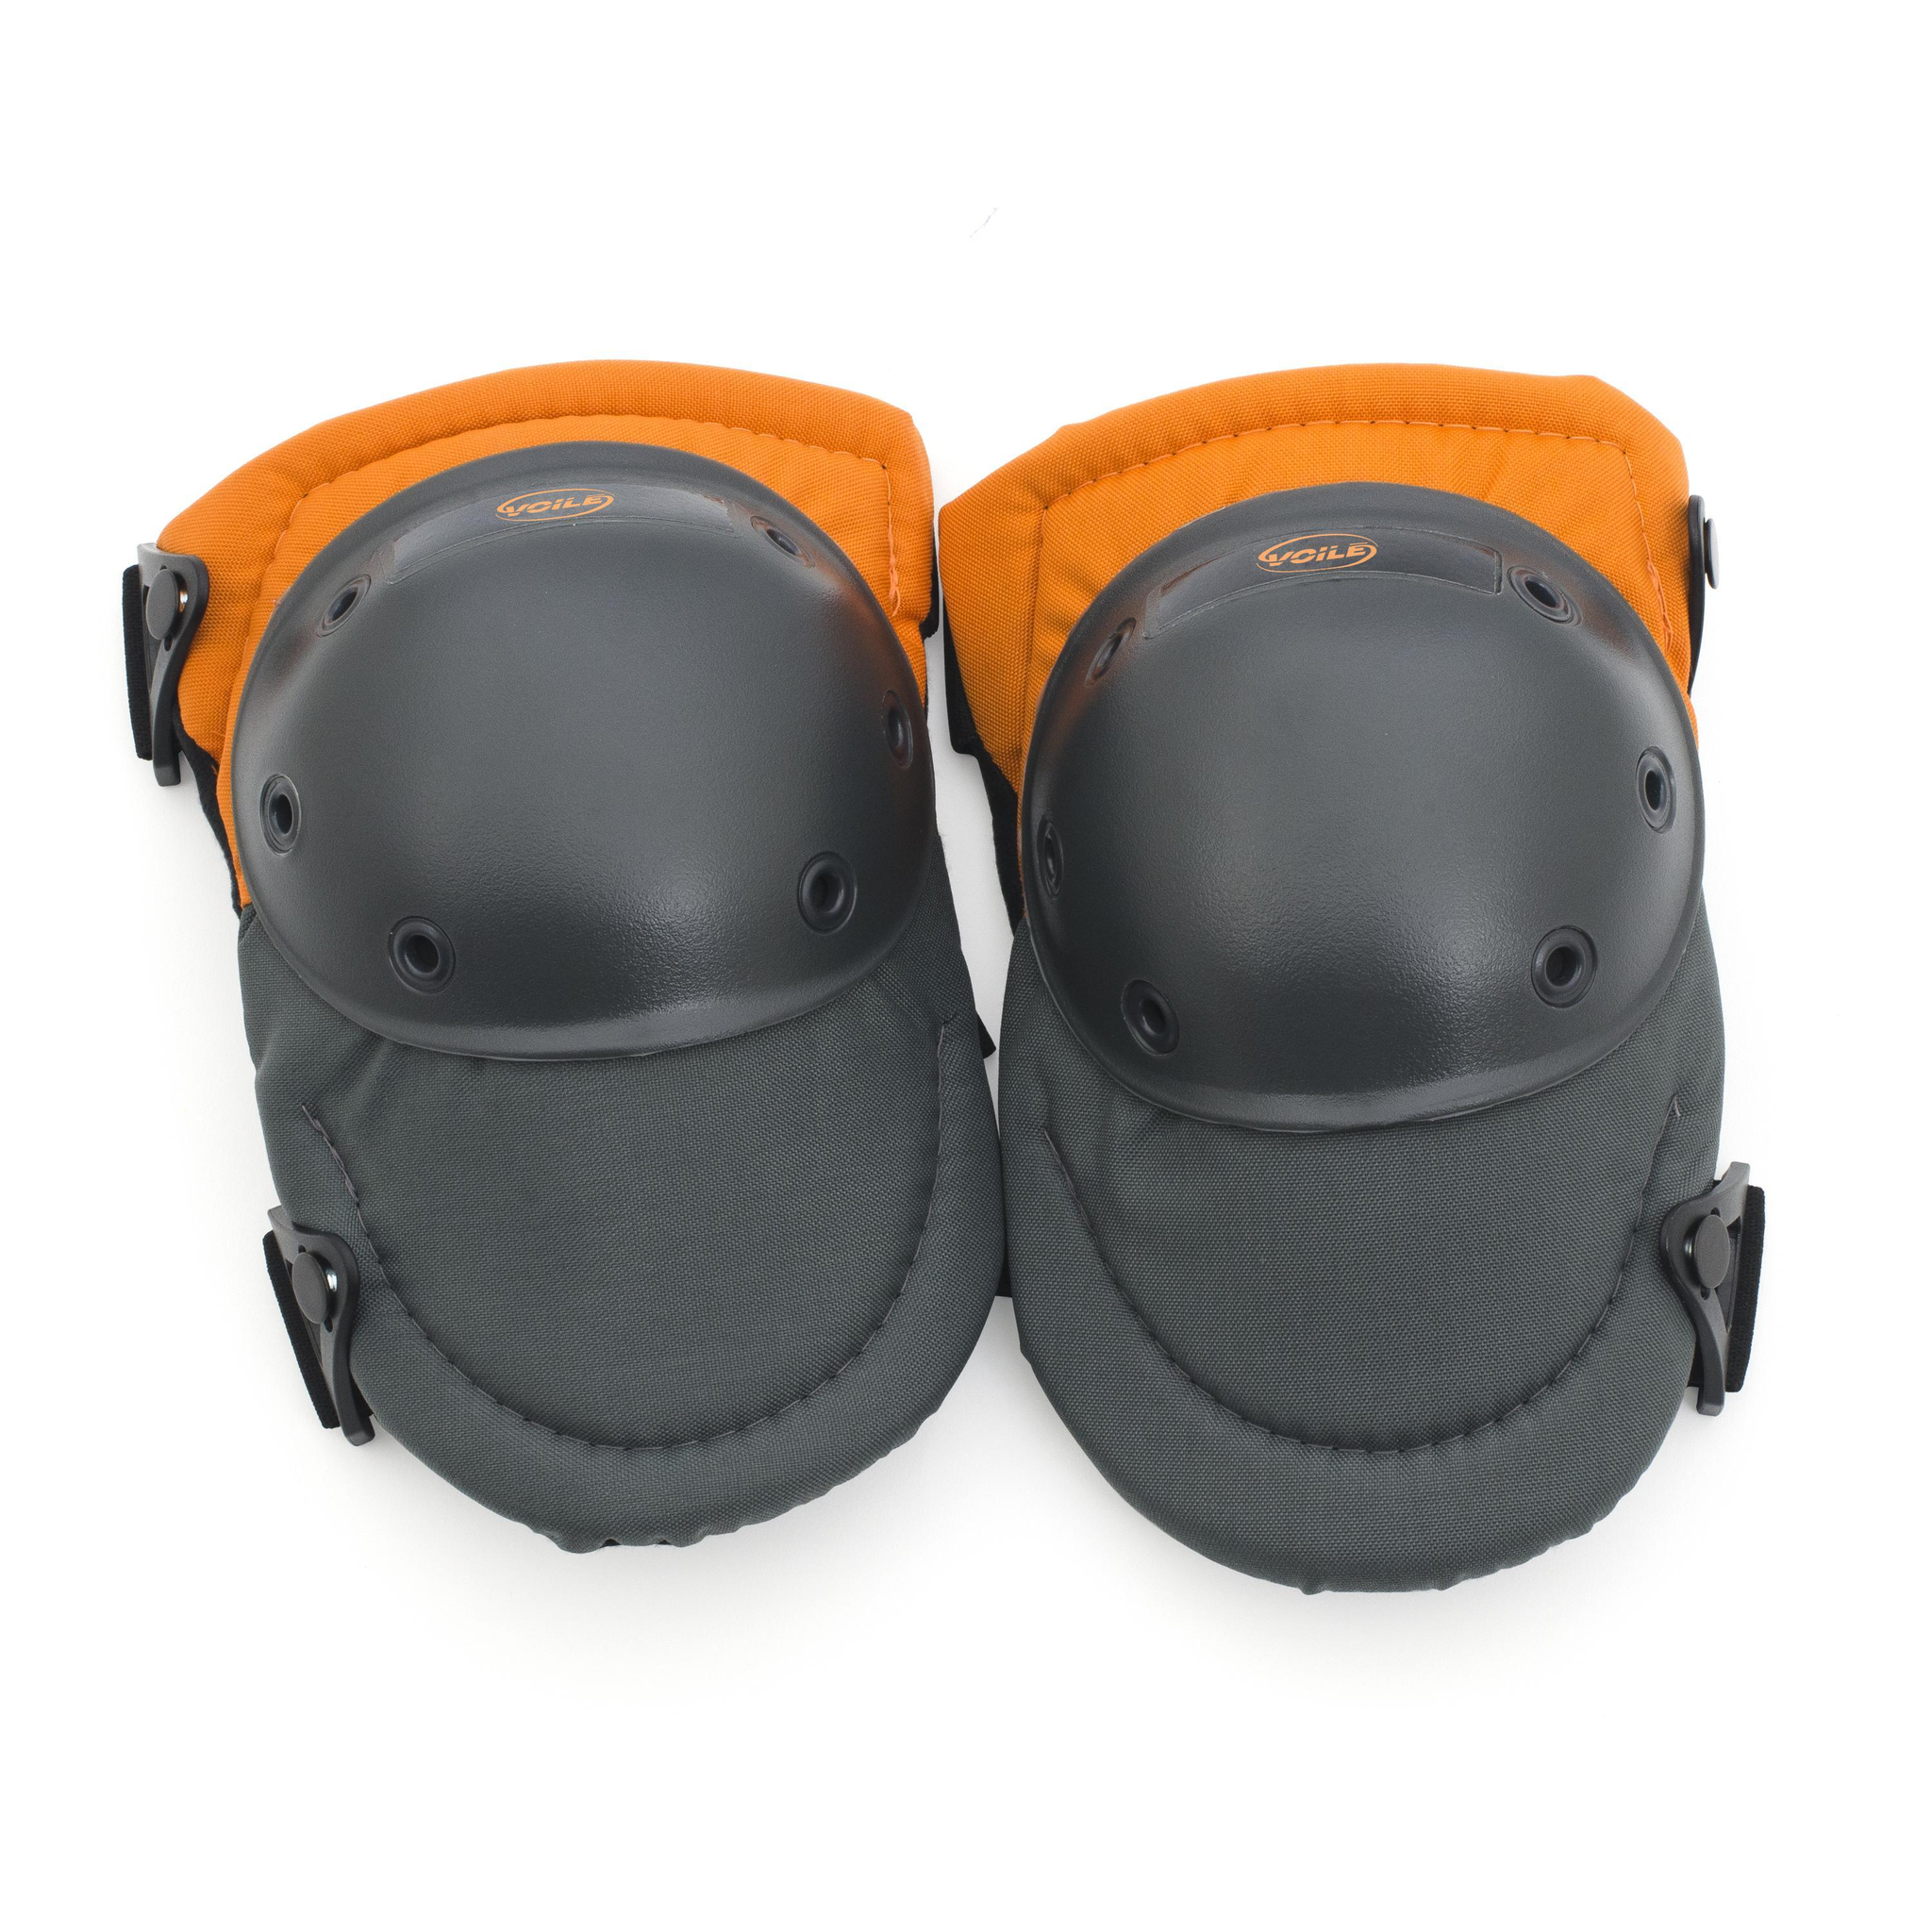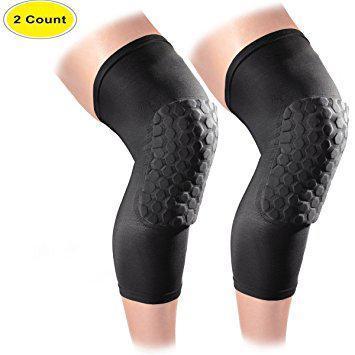The first image is the image on the left, the second image is the image on the right. Examine the images to the left and right. Is the description "There are two legs in the image on the right." accurate? Answer yes or no. Yes. 